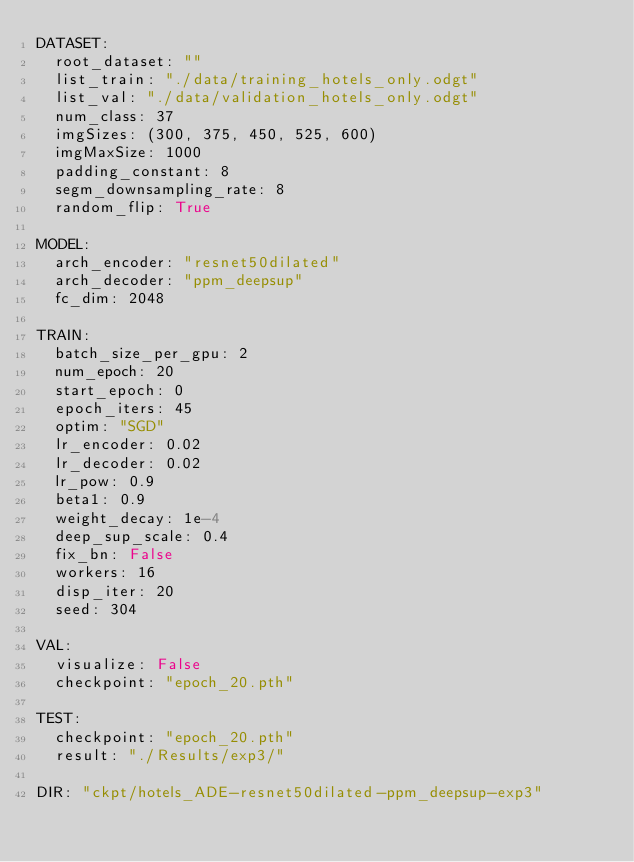Convert code to text. <code><loc_0><loc_0><loc_500><loc_500><_YAML_>DATASET:
  root_dataset: ""
  list_train: "./data/training_hotels_only.odgt"
  list_val: "./data/validation_hotels_only.odgt"
  num_class: 37
  imgSizes: (300, 375, 450, 525, 600)
  imgMaxSize: 1000
  padding_constant: 8
  segm_downsampling_rate: 8
  random_flip: True

MODEL:
  arch_encoder: "resnet50dilated"
  arch_decoder: "ppm_deepsup"
  fc_dim: 2048

TRAIN:
  batch_size_per_gpu: 2
  num_epoch: 20
  start_epoch: 0
  epoch_iters: 45
  optim: "SGD"
  lr_encoder: 0.02
  lr_decoder: 0.02  
  lr_pow: 0.9
  beta1: 0.9
  weight_decay: 1e-4
  deep_sup_scale: 0.4
  fix_bn: False
  workers: 16
  disp_iter: 20
  seed: 304

VAL:
  visualize: False
  checkpoint: "epoch_20.pth"

TEST:
  checkpoint: "epoch_20.pth"
  result: "./Results/exp3/"

DIR: "ckpt/hotels_ADE-resnet50dilated-ppm_deepsup-exp3"
</code> 